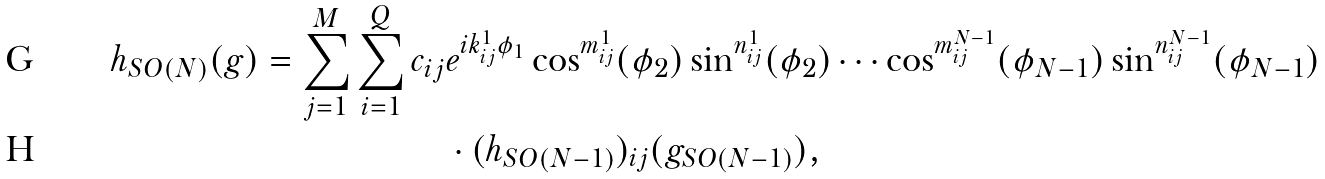Convert formula to latex. <formula><loc_0><loc_0><loc_500><loc_500>h _ { S O ( N ) } ( g ) = \sum _ { j = 1 } ^ { M } \sum _ { i = 1 } ^ { Q } c _ { i j } & e ^ { i k _ { i j } ^ { 1 } \phi _ { 1 } } \cos ^ { m _ { i j } ^ { 1 } } ( \phi _ { 2 } ) \sin ^ { n _ { i j } ^ { 1 } } ( \phi _ { 2 } ) \cdots \cos ^ { m _ { i j } ^ { N - 1 } } ( \phi _ { N - 1 } ) \sin ^ { n _ { i j } ^ { N - 1 } } ( \phi _ { N - 1 } ) \\ & \cdot ( h _ { S O ( N - 1 ) } ) _ { i j } ( g _ { S O ( N - 1 ) } ) ,</formula> 